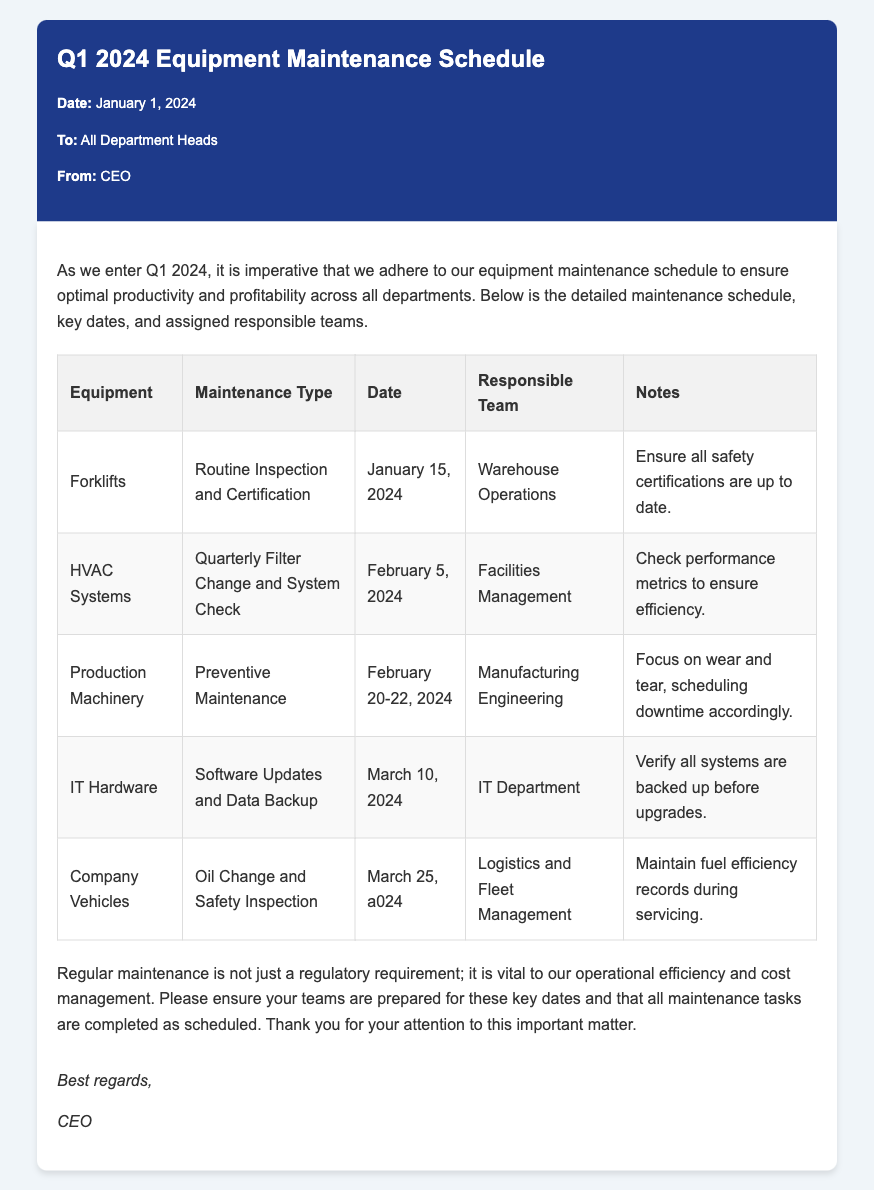What is the date of the memo? The date of the memo is stated in the meta-info section at the top of the document.
Answer: January 1, 2024 Who is the memo addressed to? The memo indicates the recipient in the meta-info section, which identifies the audience of the communication.
Answer: All Department Heads What type of maintenance is scheduled for Forklifts? The memo specifies the type of maintenance in the table for each piece of equipment.
Answer: Routine Inspection and Certification When is the maintenance for HVAC Systems scheduled? The date for HVAC Systems maintenance is listed in the table, showing when this specific task will occur.
Answer: February 5, 2024 Which team is responsible for IT Hardware maintenance? The responsible team for each maintenance task is detailed in the third column of the maintenance schedule table.
Answer: IT Department How many days is the preventive maintenance scheduled for Production Machinery? The schedule shows the date range for Production Machinery maintenance, indicating the duration of the task.
Answer: 3 days What are the notes for the Company Vehicles maintenance task? The notes section provides additional instructions or considerations for each maintenance type listed in the table.
Answer: Maintain fuel efficiency records during servicing Why is regular maintenance emphasized in the conclusion? The conclusion summarizes the importance of maintenance based on the overall context and purpose of the memo.
Answer: Operational efficiency and cost management 